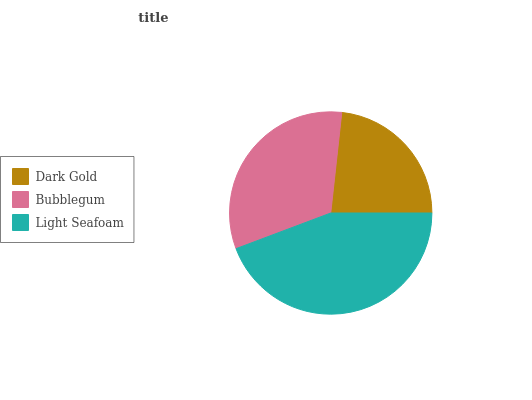Is Dark Gold the minimum?
Answer yes or no. Yes. Is Light Seafoam the maximum?
Answer yes or no. Yes. Is Bubblegum the minimum?
Answer yes or no. No. Is Bubblegum the maximum?
Answer yes or no. No. Is Bubblegum greater than Dark Gold?
Answer yes or no. Yes. Is Dark Gold less than Bubblegum?
Answer yes or no. Yes. Is Dark Gold greater than Bubblegum?
Answer yes or no. No. Is Bubblegum less than Dark Gold?
Answer yes or no. No. Is Bubblegum the high median?
Answer yes or no. Yes. Is Bubblegum the low median?
Answer yes or no. Yes. Is Dark Gold the high median?
Answer yes or no. No. Is Light Seafoam the low median?
Answer yes or no. No. 